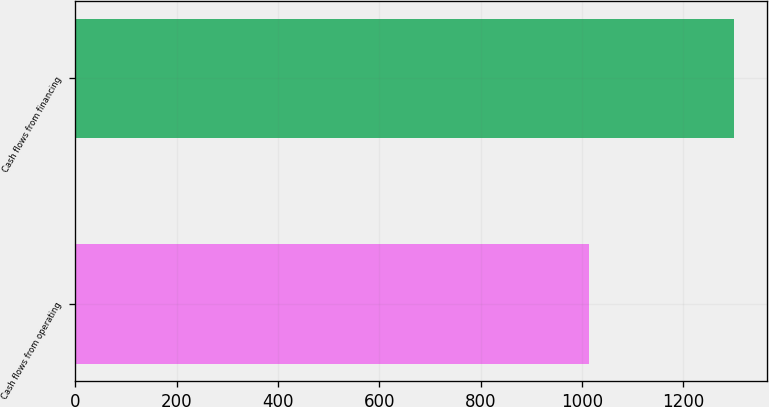<chart> <loc_0><loc_0><loc_500><loc_500><bar_chart><fcel>Cash flows from operating<fcel>Cash flows from financing<nl><fcel>1014.1<fcel>1300.7<nl></chart> 